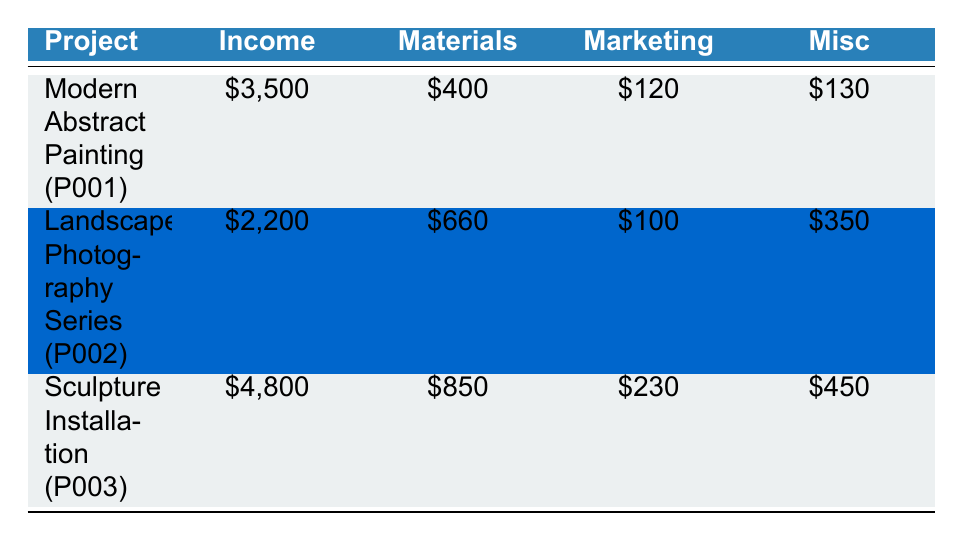What is the total income generated from the "Sculpture Installation" project? The income for the "Sculpture Installation" project is listed under the Income column. It has two sources: Commission from Public Park ($3000) and Art Fair Sales ($1800). Adding these amounts, we get 3000 + 1800 = 4800.
Answer: 4800 Which project had the highest marketing expenses? To find the project with the highest marketing expenses, we look at the Marketing column. "Modern Abstract Painting" has $120, "Landscape Photography Series" has $100, and "Sculpture Installation" has $230. The highest amount is $230 for "Sculpture Installation".
Answer: Sculpture Installation What is the total expense for the "Landscape Photography Series"? The total expense is found by summing all the expense categories: Materials ($660) + Marketing ($100) + Miscellaneous ($350) = 660 + 100 + 350 = 1110.
Answer: 1110 Did the "Modern Abstract Painting" project generate more income than the "Landscape Photography Series"? The income for "Modern Abstract Painting" is $3500, while "Landscape Photography Series" generated $2200. Since 3500 is greater than 2200, the statement is true.
Answer: Yes What is the average income across all three art projects? The total income is calculated as follows: $3500 (Modern Abstract Painting) + $2200 (Landscape Photography Series) + $4800 (Sculpture Installation) = $10500. Since there are three projects, we divide by 3, giving us 10500 / 3 = 3500.
Answer: 3500 